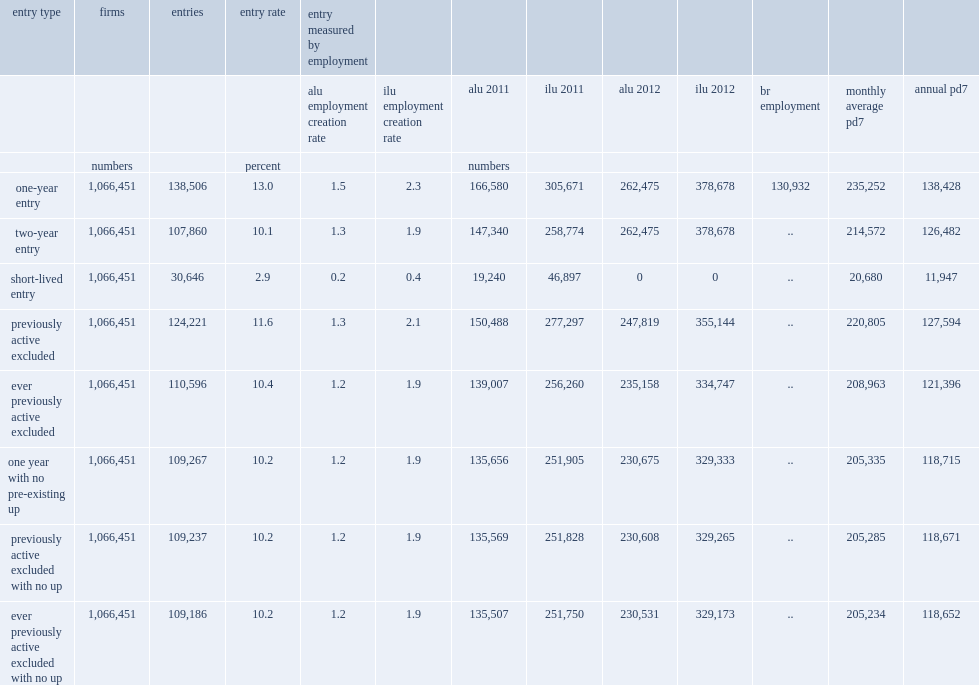What is the entry rate of enterprises consisted of the group of short-lived firms? 2.9. What is the total number of entrants in 2011? 138506.0. How many alus do entrants in 2011 account for? 166580.0. How many ilus do entrants in 2011 account for? 305671.0. How much percentage of employment using full-time equivalents do entrants account for if the first-year size of entrants is used? 1.5. How much percentage of employment using person-job counts do entrants account for if the first-year size of entrants is used? 2.3. How much percentage of employment using full-time equivalents do entrants account for if the second-year size of entrants is used? 1.3. How much percentage of employment using person-job counts do entrants account for if the second-year size of entrants is used? 1.9. 